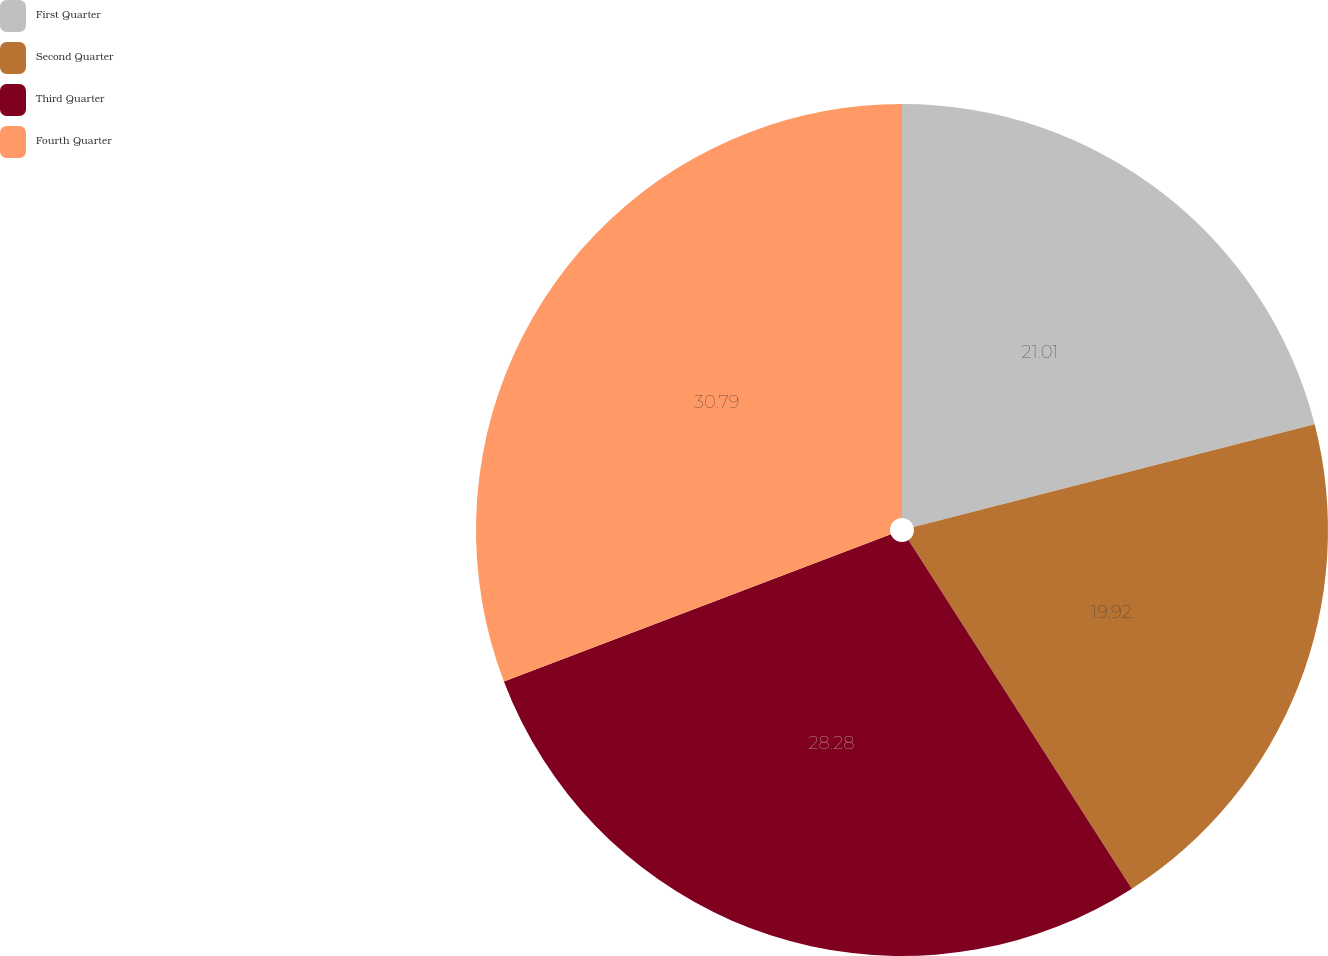Convert chart to OTSL. <chart><loc_0><loc_0><loc_500><loc_500><pie_chart><fcel>First Quarter<fcel>Second Quarter<fcel>Third Quarter<fcel>Fourth Quarter<nl><fcel>21.01%<fcel>19.92%<fcel>28.28%<fcel>30.79%<nl></chart> 